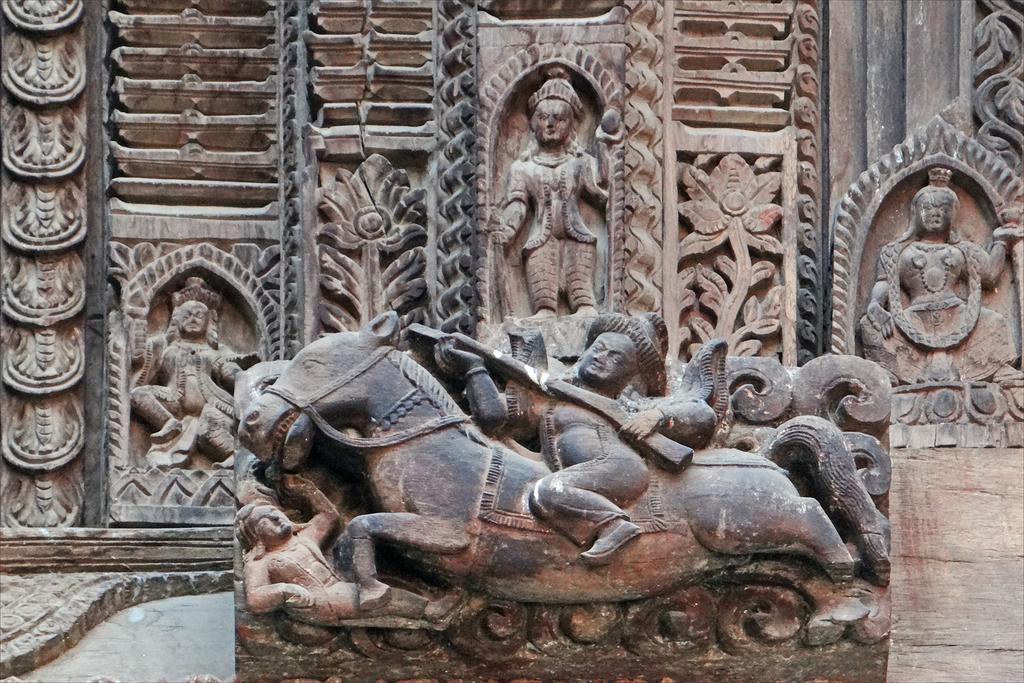What is on the wall in the image? There is a sculpture on the wall in the image. What type of root can be seen growing from the toad in the image? There is no toad or root present in the image; it features a sculpture on the wall. What type of bird is perched on the sculpture in the image? There is no bird present in the image; it features a sculpture on the wall. 